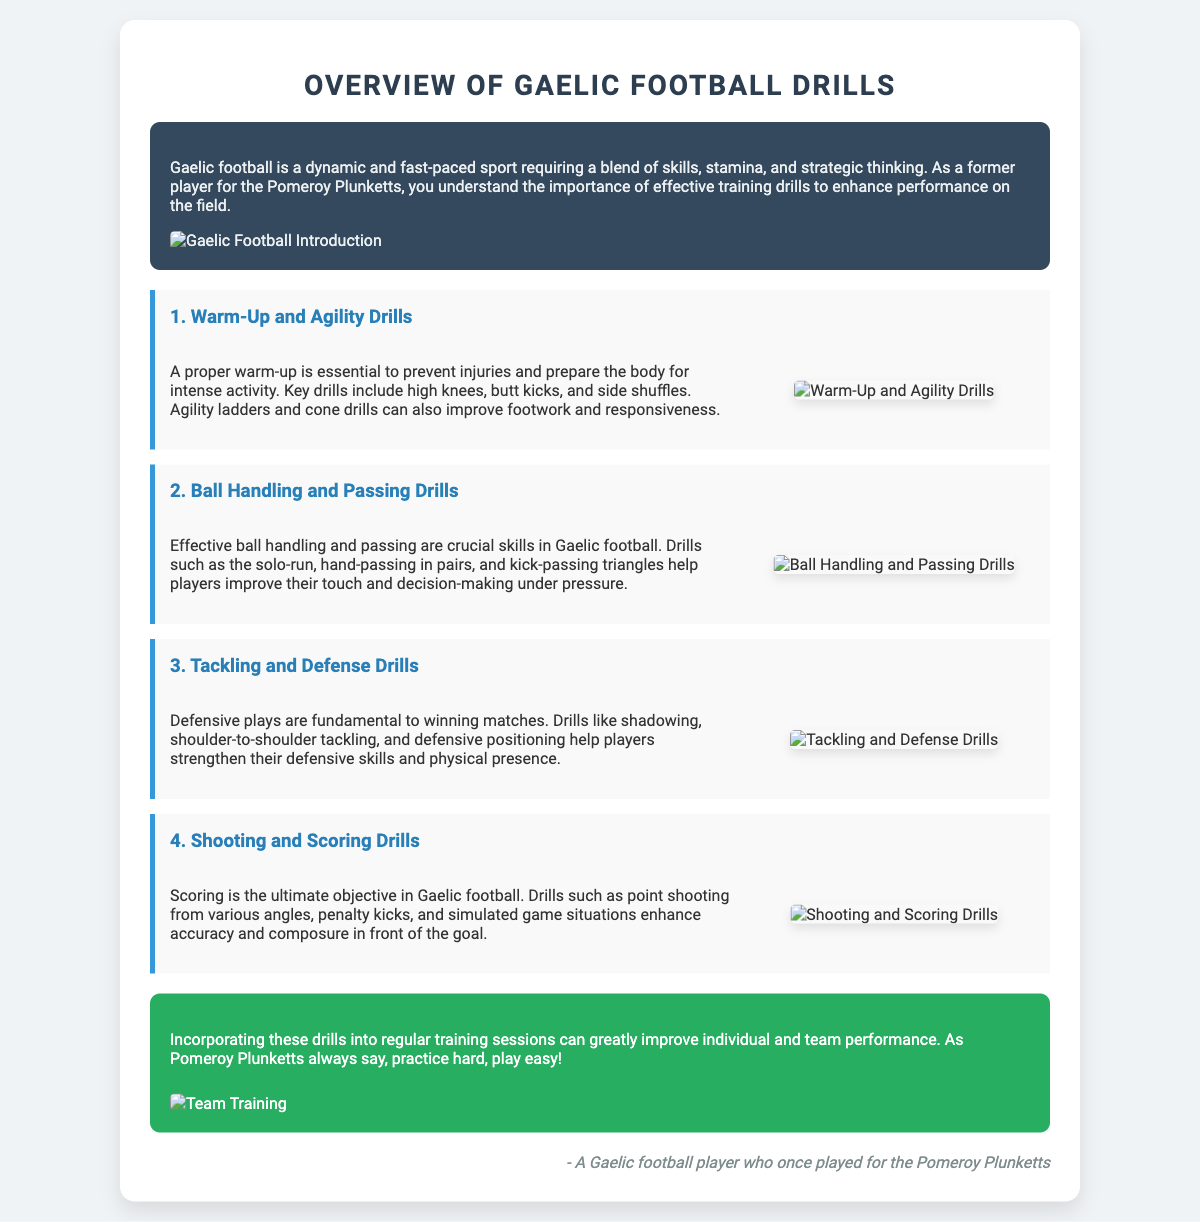What is the title of the presentation slide? The title of the presentation slide is provided at the top of the document and it is "Overview of Gaelic Football Drills."
Answer: Overview of Gaelic Football Drills What is the first drill mentioned? The first drill is identified in the document and is titled "Warm-Up and Agility Drills."
Answer: Warm-Up and Agility Drills How many types of drills are listed in the presentation? The document enumerates four types of drills aimed at improving different skills in Gaelic football.
Answer: Four What is emphasized as crucial for player performance? The text highlights the importance of various training drills for enhancing performance on the field in Gaelic football.
Answer: Effective training drills What color is the background of the conclusion section? The background color of the conclusion section is displayed prominently in the document as green.
Answer: Green What is the ultimate objective in Gaelic football according to the drills? The document states that scoring is the ultimate objective in Gaelic football, emphasizing its significance in the sport.
Answer: Scoring Which aspect of training focuses on preventing injuries? The warm-up drills are specifically noted in the text to prepare the body for exercise and prevent injuries.
Answer: Warm-Up What is stated about practice and performance at the end of the presentation? The conclusion emphasizes that practicing hard results in playing easy, a philosophy echoed by the Pomeroy Plunketts.
Answer: Practice hard, play easy What type of training drill involves ball handling? The second drill discussed focuses on skills related to ball handling and passing.
Answer: Ball Handling and Passing Drills 